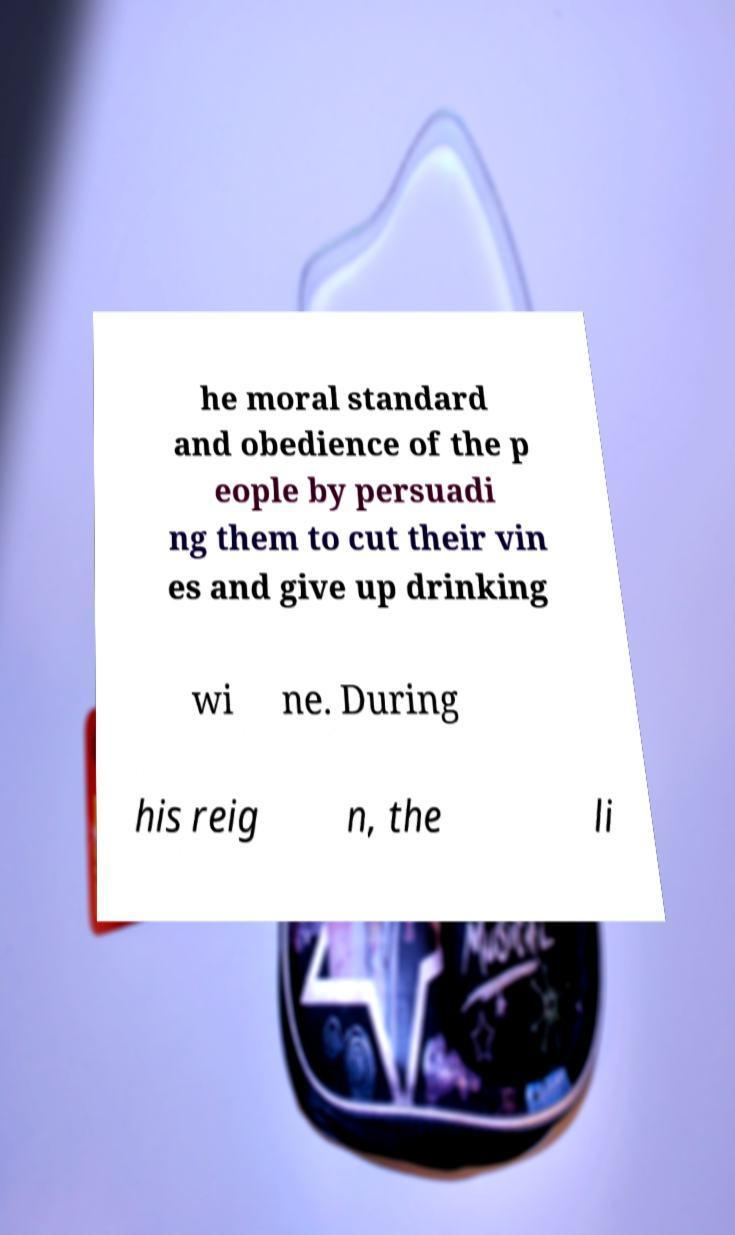Please read and relay the text visible in this image. What does it say? he moral standard and obedience of the p eople by persuadi ng them to cut their vin es and give up drinking wi ne. During his reig n, the li 